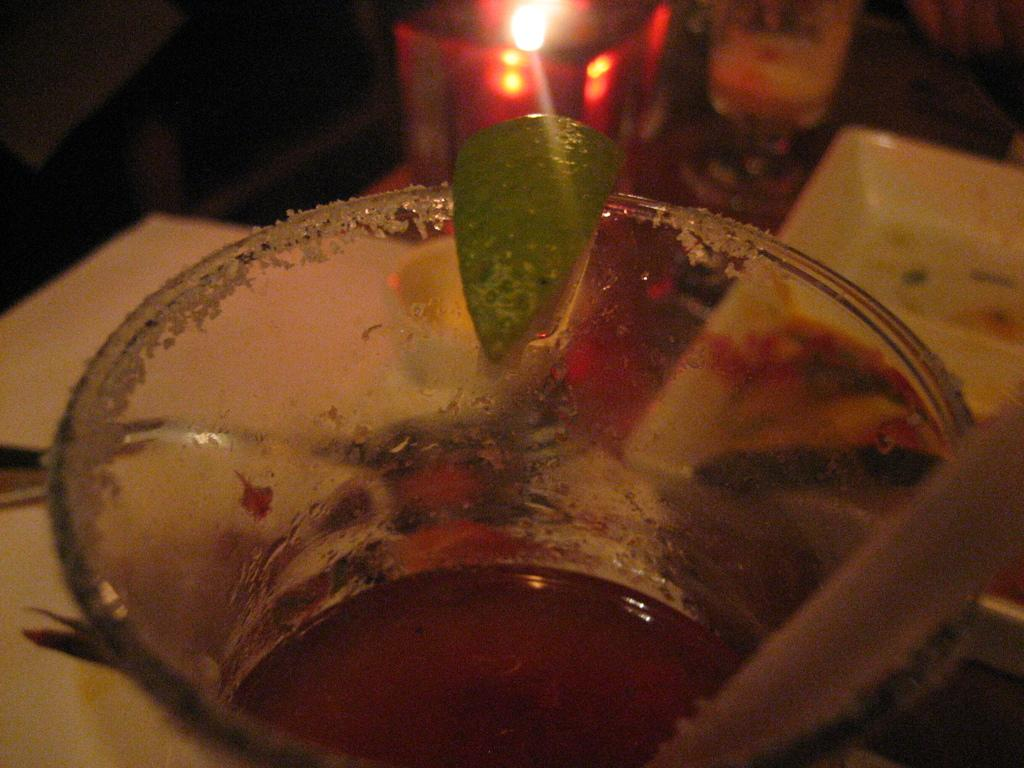What type of plant material is present in the image? There is a green leaf in the image. What is used for drinking in the image? There is a straw in the image. What is the glass in the image holding? There is a glass with a drink in the image. What can be seen in the background of the image? There is a candle and a plate in the background of the image. What suggestion does the leaf provide in the image? The leaf does not provide any suggestions in the image; it is simply a green leaf. What substance is being consumed through the straw in the image? The image does not specify the type of drink in the glass, so we cannot determine the substance being consumed through the straw. 